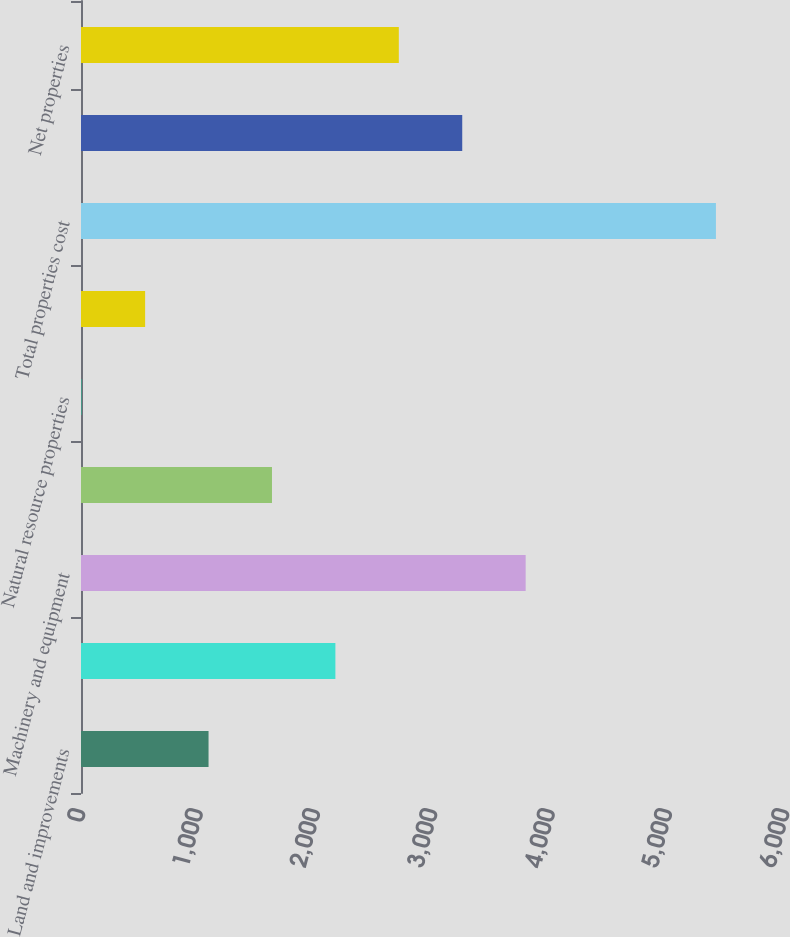<chart> <loc_0><loc_0><loc_500><loc_500><bar_chart><fcel>Land and improvements<fcel>Buildings and improvements<fcel>Machinery and equipment<fcel>Furniture and fixtures<fcel>Natural resource properties<fcel>Construction in progress<fcel>Total properties cost<fcel>Less accumulated depreciation<fcel>Net properties<nl><fcel>1087.06<fcel>2168.12<fcel>3789.71<fcel>1627.59<fcel>6<fcel>546.53<fcel>5411.3<fcel>3249.18<fcel>2708.65<nl></chart> 